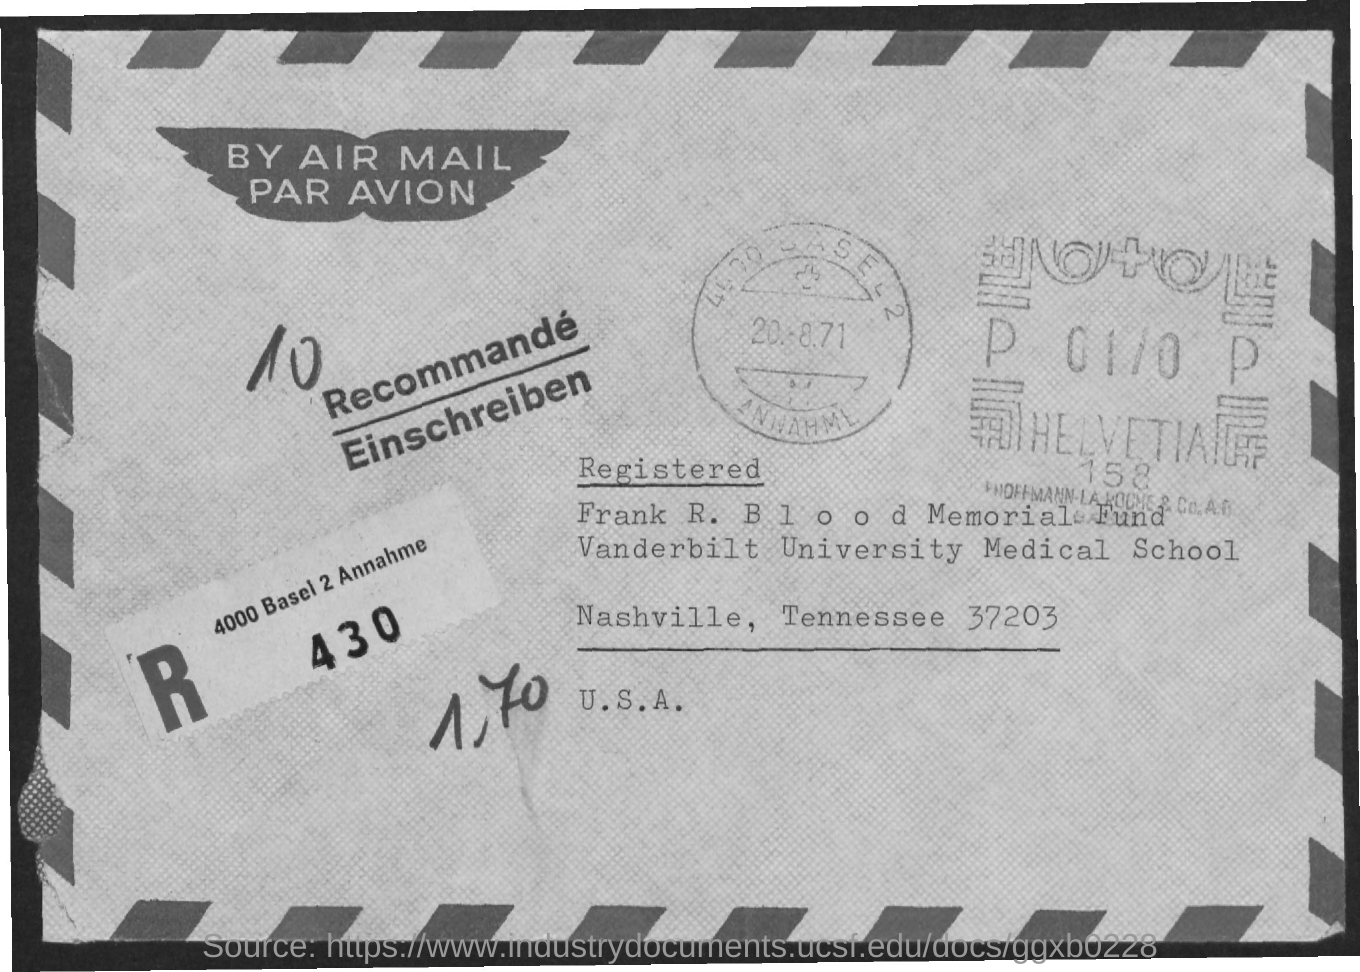What is the name of the university mentioned ?
Keep it short and to the point. Vanderbilt university medical school. 